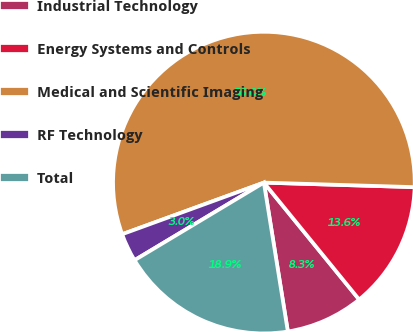<chart> <loc_0><loc_0><loc_500><loc_500><pie_chart><fcel>Industrial Technology<fcel>Energy Systems and Controls<fcel>Medical and Scientific Imaging<fcel>RF Technology<fcel>Total<nl><fcel>8.34%<fcel>13.64%<fcel>56.04%<fcel>3.04%<fcel>18.94%<nl></chart> 